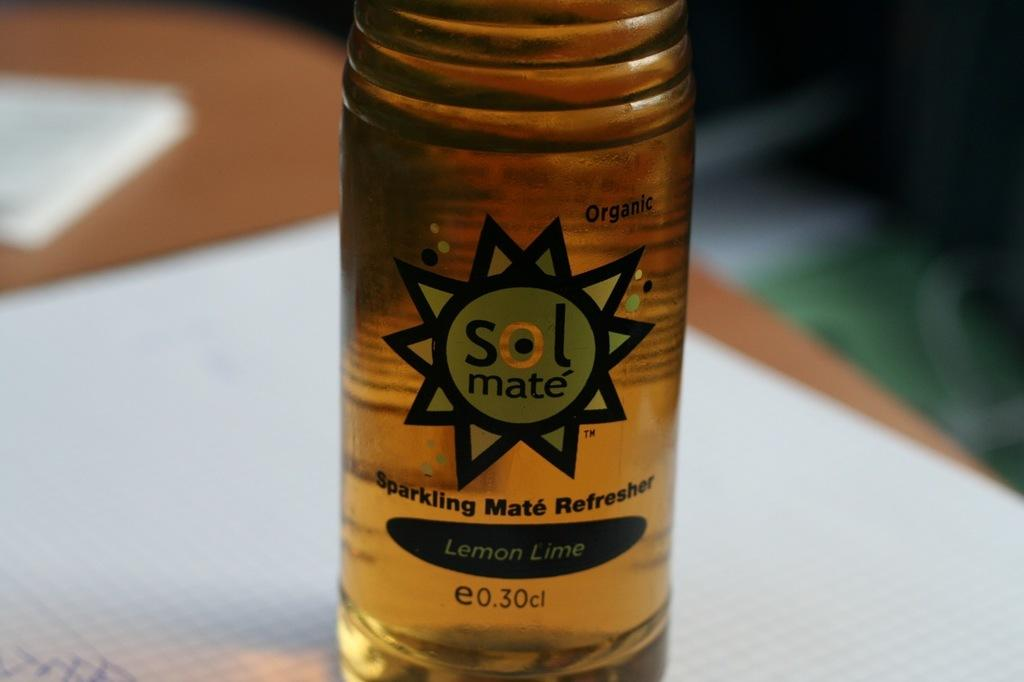What object is present on the white surface in the image? There is a tin on a white surface in the image. Can you describe the background of the image? The background of the image is blurred. What type of button can be seen on the ground in the image? There is no button or ground present in the image; it only features a tin on a white surface with a blurred background. 